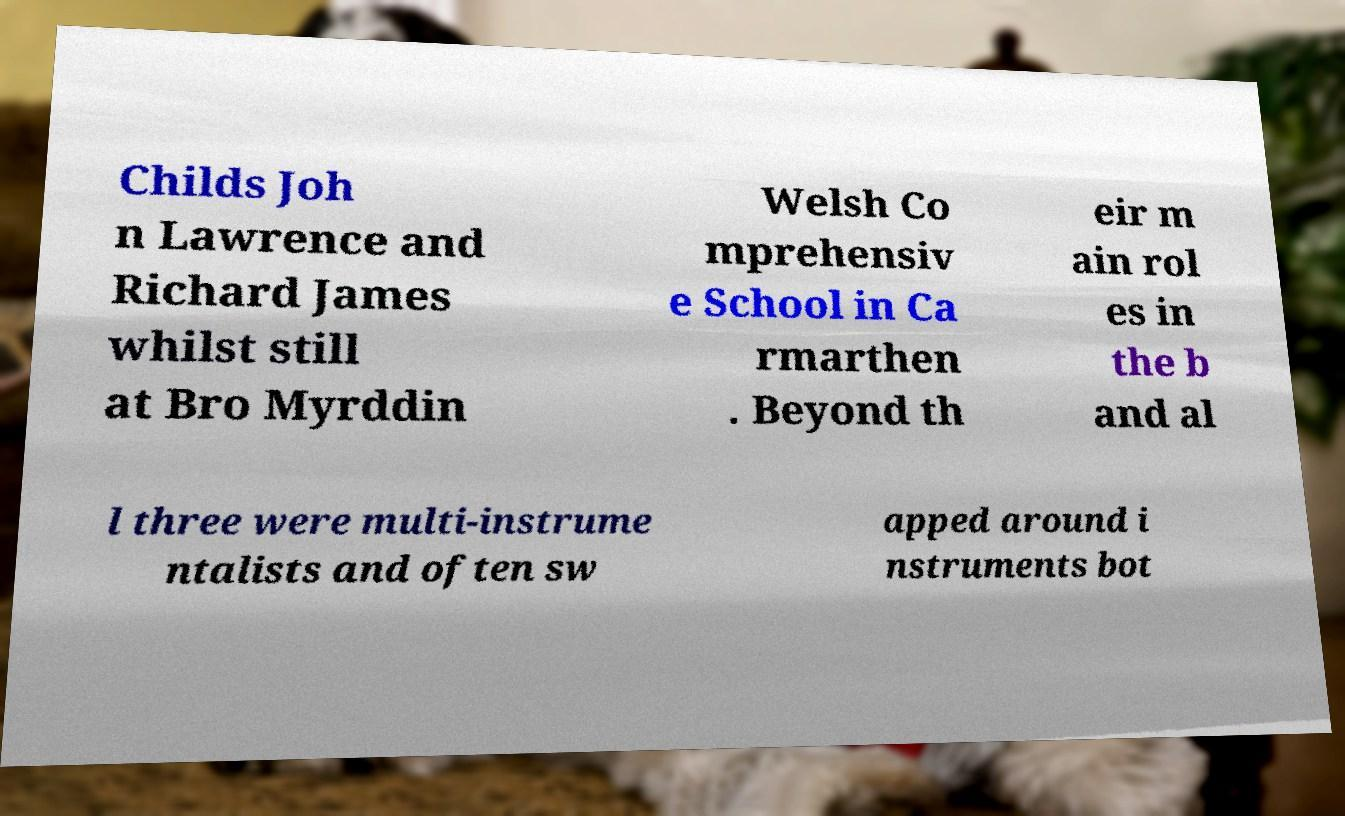Could you extract and type out the text from this image? Childs Joh n Lawrence and Richard James whilst still at Bro Myrddin Welsh Co mprehensiv e School in Ca rmarthen . Beyond th eir m ain rol es in the b and al l three were multi-instrume ntalists and often sw apped around i nstruments bot 